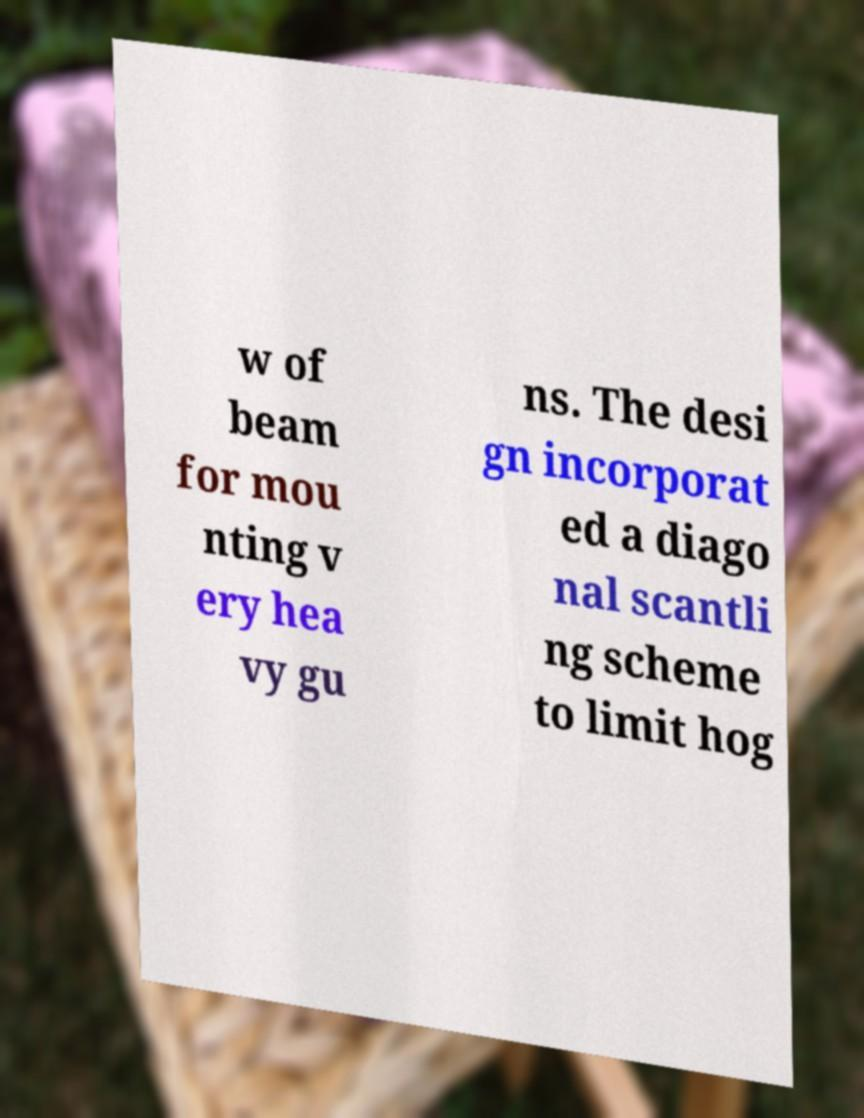For documentation purposes, I need the text within this image transcribed. Could you provide that? w of beam for mou nting v ery hea vy gu ns. The desi gn incorporat ed a diago nal scantli ng scheme to limit hog 